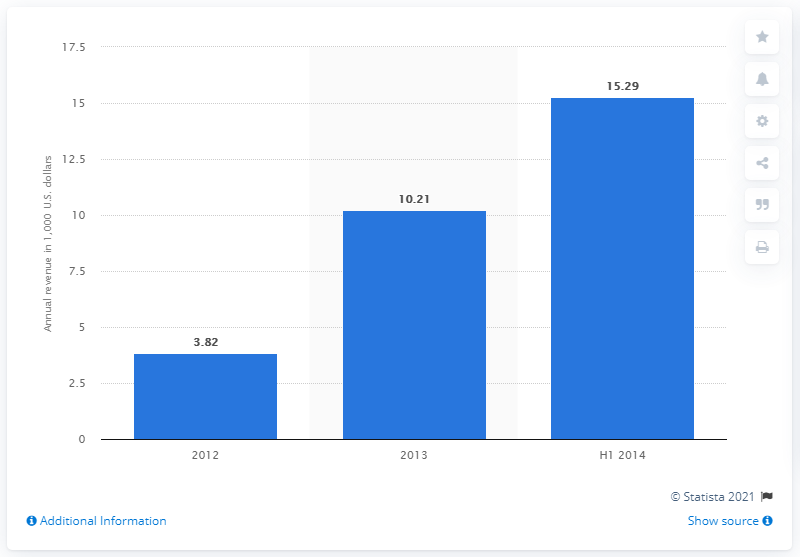Outline some significant characteristics in this image. In the most recent quarter of 2014, the revenue of WhatsApp was 15.29. In the previous fiscal year, WhatsApp's revenue was approximately 10.21. 